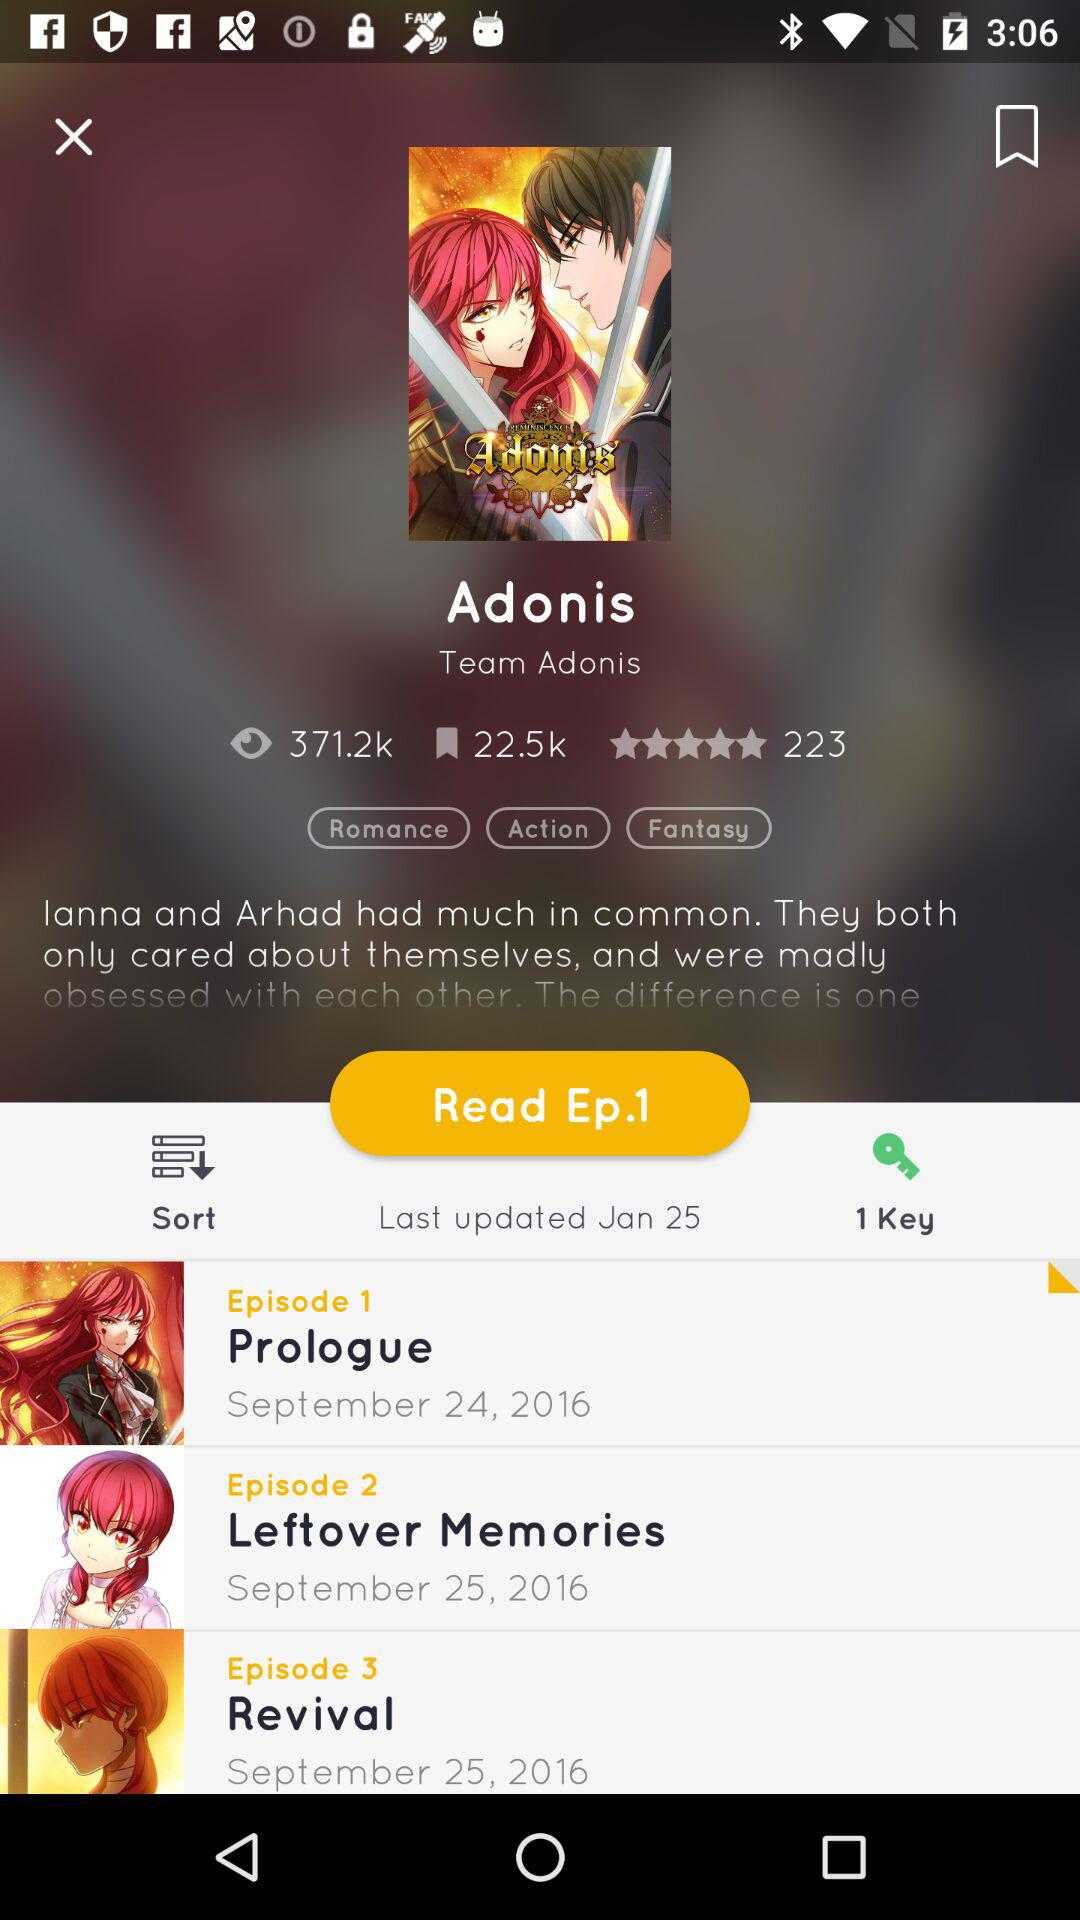How many episodes are there for the Adonis series?
Answer the question using a single word or phrase. 3 